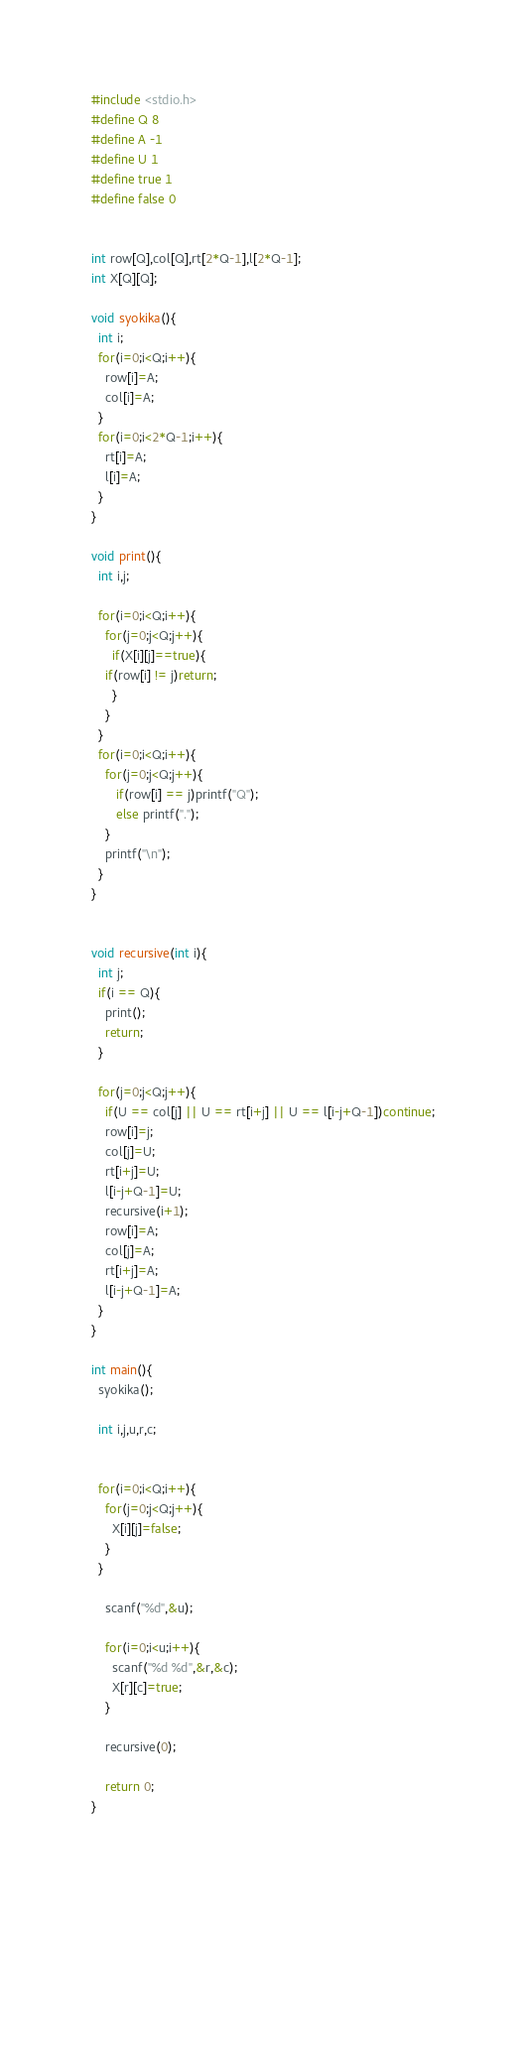<code> <loc_0><loc_0><loc_500><loc_500><_C_>#include <stdio.h>
#define Q 8
#define A -1
#define U 1
#define true 1
#define false 0


int row[Q],col[Q],rt[2*Q-1],l[2*Q-1];
int X[Q][Q];

void syokika(){
  int i;
  for(i=0;i<Q;i++){
    row[i]=A;
    col[i]=A;
  }
  for(i=0;i<2*Q-1;i++){
    rt[i]=A;
    l[i]=A;
  }
}

void print(){
  int i,j;

  for(i=0;i<Q;i++){
    for(j=0;j<Q;j++){
      if(X[i][j]==true){
	if(row[i] != j)return;
      }
    }
  }
  for(i=0;i<Q;i++){
    for(j=0;j<Q;j++){
       if(row[i] == j)printf("Q");
       else printf(".");
    }
    printf("\n");
  }
}


void recursive(int i){
  int j;
  if(i == Q){
    print();
    return;
  }

  for(j=0;j<Q;j++){
    if(U == col[j] || U == rt[i+j] || U == l[i-j+Q-1])continue;
    row[i]=j;
    col[j]=U;
    rt[i+j]=U;
    l[i-j+Q-1]=U;
    recursive(i+1);
    row[i]=A;
    col[j]=A;
    rt[i+j]=A;
    l[i-j+Q-1]=A;
  }
}

int main(){
  syokika();

  int i,j,u,r,c;
  

  for(i=0;i<Q;i++){
    for(j=0;j<Q;j++){
      X[i][j]=false;
    }
  }

    scanf("%d",&u);

    for(i=0;i<u;i++){
      scanf("%d %d",&r,&c);
      X[r][c]=true;
    }

    recursive(0);

    return 0;
}

      


  
    
	     

</code> 